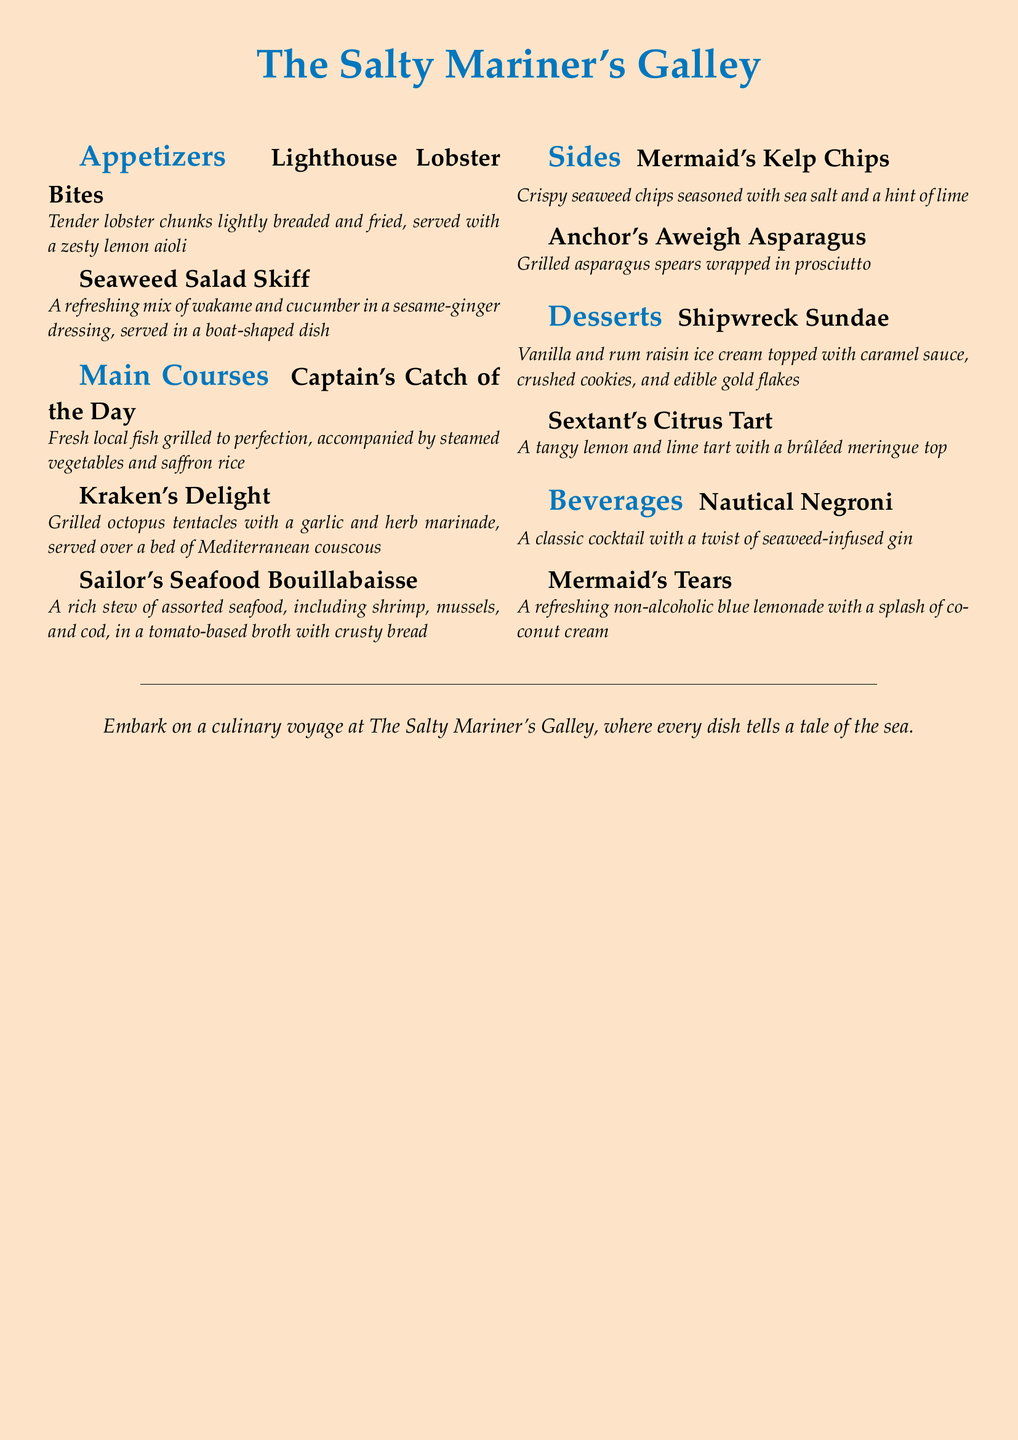What is the name of the restaurant? The name of the restaurant is prominently displayed at the top of the menu.
Answer: The Salty Mariner's Galley How many appetizers are listed on the menu? The menu specifically lists two appetizers under the Appetizers section.
Answer: 2 What is the main ingredient in the "Captain's Catch of the Day"? The main ingredient is specified as the fresh local fish in the description of the dish.
Answer: Fish What is the dessert that includes ice cream? The dessert with ice cream is mentioned in the Desserts section of the menu.
Answer: Shipwreck Sundae What type of salad is served in the boat-shaped dish? The salad is described under the Appetizers section, specifying the type of salad and its presentation.
Answer: Seaweed Salad Skiff Which side dish includes asparagus? The document lists a specific side dish that features asparagus wrapped in another ingredient.
Answer: Anchor's Aweigh Asparagus How is the "Kraken's Delight" prepared? The preparation method is highlighted in the name and description of the dish within the menu.
Answer: Grilled What beverage is infused with seaweed? The beverage section mentions a drink with a unique flavor profile.
Answer: Nautical Negroni What section includes the "Sailor's Seafood Bouillabaisse"? The section where this dish is located is stated in the document structure.
Answer: Main Courses 